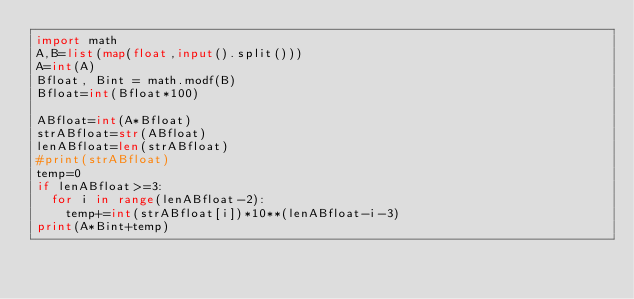<code> <loc_0><loc_0><loc_500><loc_500><_Python_>import math
A,B=list(map(float,input().split()))
A=int(A)
Bfloat, Bint = math.modf(B)
Bfloat=int(Bfloat*100)

ABfloat=int(A*Bfloat)
strABfloat=str(ABfloat)
lenABfloat=len(strABfloat)
#print(strABfloat)
temp=0
if lenABfloat>=3:
  for i in range(lenABfloat-2):
    temp+=int(strABfloat[i])*10**(lenABfloat-i-3)  
print(A*Bint+temp)</code> 